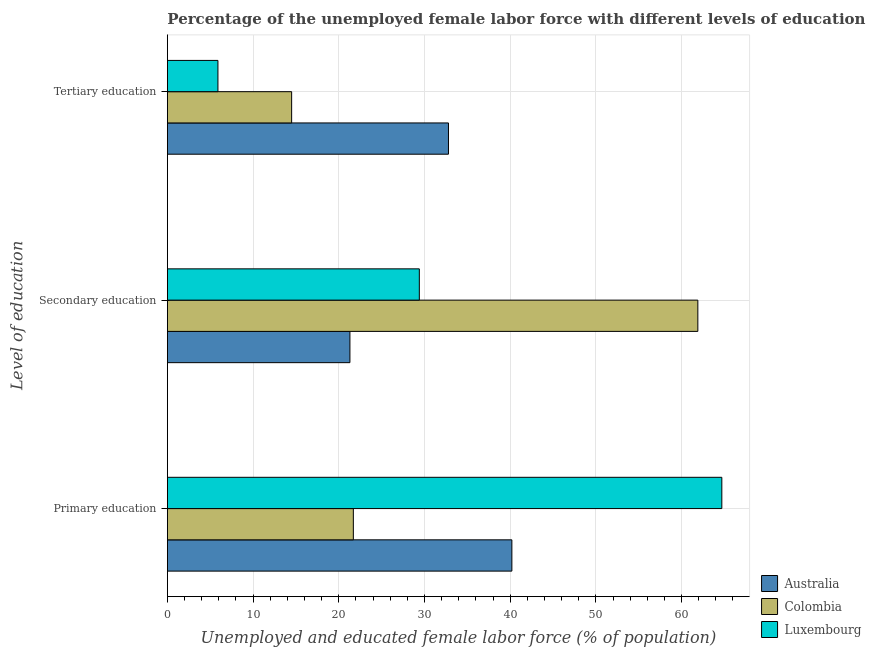How many different coloured bars are there?
Give a very brief answer. 3. How many groups of bars are there?
Give a very brief answer. 3. Are the number of bars per tick equal to the number of legend labels?
Give a very brief answer. Yes. How many bars are there on the 1st tick from the top?
Provide a succinct answer. 3. What is the label of the 2nd group of bars from the top?
Your answer should be very brief. Secondary education. What is the percentage of female labor force who received primary education in Colombia?
Offer a terse response. 21.7. Across all countries, what is the maximum percentage of female labor force who received primary education?
Ensure brevity in your answer.  64.7. Across all countries, what is the minimum percentage of female labor force who received secondary education?
Keep it short and to the point. 21.3. In which country was the percentage of female labor force who received tertiary education maximum?
Offer a terse response. Australia. In which country was the percentage of female labor force who received primary education minimum?
Offer a terse response. Colombia. What is the total percentage of female labor force who received tertiary education in the graph?
Provide a short and direct response. 53.2. What is the difference between the percentage of female labor force who received primary education in Colombia and that in Luxembourg?
Your answer should be compact. -43. What is the difference between the percentage of female labor force who received secondary education in Luxembourg and the percentage of female labor force who received primary education in Australia?
Make the answer very short. -10.8. What is the average percentage of female labor force who received tertiary education per country?
Give a very brief answer. 17.73. What is the difference between the percentage of female labor force who received tertiary education and percentage of female labor force who received secondary education in Australia?
Offer a very short reply. 11.5. In how many countries, is the percentage of female labor force who received primary education greater than 4 %?
Your answer should be very brief. 3. What is the ratio of the percentage of female labor force who received tertiary education in Luxembourg to that in Australia?
Your answer should be very brief. 0.18. Is the percentage of female labor force who received primary education in Australia less than that in Luxembourg?
Make the answer very short. Yes. Is the difference between the percentage of female labor force who received primary education in Luxembourg and Australia greater than the difference between the percentage of female labor force who received secondary education in Luxembourg and Australia?
Offer a very short reply. Yes. What is the difference between the highest and the second highest percentage of female labor force who received tertiary education?
Provide a succinct answer. 18.3. What is the difference between the highest and the lowest percentage of female labor force who received primary education?
Provide a short and direct response. 43. What does the 3rd bar from the top in Primary education represents?
Give a very brief answer. Australia. What does the 1st bar from the bottom in Primary education represents?
Provide a short and direct response. Australia. Is it the case that in every country, the sum of the percentage of female labor force who received primary education and percentage of female labor force who received secondary education is greater than the percentage of female labor force who received tertiary education?
Provide a short and direct response. Yes. Are all the bars in the graph horizontal?
Offer a terse response. Yes. How many countries are there in the graph?
Ensure brevity in your answer.  3. What is the difference between two consecutive major ticks on the X-axis?
Your answer should be very brief. 10. Does the graph contain any zero values?
Give a very brief answer. No. Does the graph contain grids?
Ensure brevity in your answer.  Yes. Where does the legend appear in the graph?
Your answer should be compact. Bottom right. How are the legend labels stacked?
Your response must be concise. Vertical. What is the title of the graph?
Provide a succinct answer. Percentage of the unemployed female labor force with different levels of education in countries. Does "Sao Tome and Principe" appear as one of the legend labels in the graph?
Give a very brief answer. No. What is the label or title of the X-axis?
Make the answer very short. Unemployed and educated female labor force (% of population). What is the label or title of the Y-axis?
Offer a very short reply. Level of education. What is the Unemployed and educated female labor force (% of population) of Australia in Primary education?
Your response must be concise. 40.2. What is the Unemployed and educated female labor force (% of population) of Colombia in Primary education?
Your answer should be very brief. 21.7. What is the Unemployed and educated female labor force (% of population) in Luxembourg in Primary education?
Give a very brief answer. 64.7. What is the Unemployed and educated female labor force (% of population) of Australia in Secondary education?
Your response must be concise. 21.3. What is the Unemployed and educated female labor force (% of population) in Colombia in Secondary education?
Your response must be concise. 61.9. What is the Unemployed and educated female labor force (% of population) in Luxembourg in Secondary education?
Offer a terse response. 29.4. What is the Unemployed and educated female labor force (% of population) of Australia in Tertiary education?
Make the answer very short. 32.8. What is the Unemployed and educated female labor force (% of population) of Luxembourg in Tertiary education?
Keep it short and to the point. 5.9. Across all Level of education, what is the maximum Unemployed and educated female labor force (% of population) of Australia?
Provide a short and direct response. 40.2. Across all Level of education, what is the maximum Unemployed and educated female labor force (% of population) of Colombia?
Keep it short and to the point. 61.9. Across all Level of education, what is the maximum Unemployed and educated female labor force (% of population) of Luxembourg?
Your answer should be compact. 64.7. Across all Level of education, what is the minimum Unemployed and educated female labor force (% of population) in Australia?
Make the answer very short. 21.3. Across all Level of education, what is the minimum Unemployed and educated female labor force (% of population) in Luxembourg?
Offer a very short reply. 5.9. What is the total Unemployed and educated female labor force (% of population) in Australia in the graph?
Give a very brief answer. 94.3. What is the total Unemployed and educated female labor force (% of population) in Colombia in the graph?
Your answer should be compact. 98.1. What is the total Unemployed and educated female labor force (% of population) in Luxembourg in the graph?
Your answer should be compact. 100. What is the difference between the Unemployed and educated female labor force (% of population) in Australia in Primary education and that in Secondary education?
Your answer should be compact. 18.9. What is the difference between the Unemployed and educated female labor force (% of population) of Colombia in Primary education and that in Secondary education?
Offer a terse response. -40.2. What is the difference between the Unemployed and educated female labor force (% of population) of Luxembourg in Primary education and that in Secondary education?
Offer a very short reply. 35.3. What is the difference between the Unemployed and educated female labor force (% of population) in Australia in Primary education and that in Tertiary education?
Give a very brief answer. 7.4. What is the difference between the Unemployed and educated female labor force (% of population) in Luxembourg in Primary education and that in Tertiary education?
Provide a short and direct response. 58.8. What is the difference between the Unemployed and educated female labor force (% of population) in Australia in Secondary education and that in Tertiary education?
Offer a very short reply. -11.5. What is the difference between the Unemployed and educated female labor force (% of population) in Colombia in Secondary education and that in Tertiary education?
Provide a succinct answer. 47.4. What is the difference between the Unemployed and educated female labor force (% of population) of Australia in Primary education and the Unemployed and educated female labor force (% of population) of Colombia in Secondary education?
Your answer should be very brief. -21.7. What is the difference between the Unemployed and educated female labor force (% of population) in Australia in Primary education and the Unemployed and educated female labor force (% of population) in Luxembourg in Secondary education?
Provide a short and direct response. 10.8. What is the difference between the Unemployed and educated female labor force (% of population) of Colombia in Primary education and the Unemployed and educated female labor force (% of population) of Luxembourg in Secondary education?
Offer a terse response. -7.7. What is the difference between the Unemployed and educated female labor force (% of population) of Australia in Primary education and the Unemployed and educated female labor force (% of population) of Colombia in Tertiary education?
Offer a very short reply. 25.7. What is the difference between the Unemployed and educated female labor force (% of population) of Australia in Primary education and the Unemployed and educated female labor force (% of population) of Luxembourg in Tertiary education?
Provide a short and direct response. 34.3. What is the difference between the Unemployed and educated female labor force (% of population) of Colombia in Primary education and the Unemployed and educated female labor force (% of population) of Luxembourg in Tertiary education?
Offer a terse response. 15.8. What is the average Unemployed and educated female labor force (% of population) in Australia per Level of education?
Provide a succinct answer. 31.43. What is the average Unemployed and educated female labor force (% of population) in Colombia per Level of education?
Ensure brevity in your answer.  32.7. What is the average Unemployed and educated female labor force (% of population) of Luxembourg per Level of education?
Your response must be concise. 33.33. What is the difference between the Unemployed and educated female labor force (% of population) of Australia and Unemployed and educated female labor force (% of population) of Colombia in Primary education?
Keep it short and to the point. 18.5. What is the difference between the Unemployed and educated female labor force (% of population) of Australia and Unemployed and educated female labor force (% of population) of Luxembourg in Primary education?
Offer a terse response. -24.5. What is the difference between the Unemployed and educated female labor force (% of population) of Colombia and Unemployed and educated female labor force (% of population) of Luxembourg in Primary education?
Provide a succinct answer. -43. What is the difference between the Unemployed and educated female labor force (% of population) of Australia and Unemployed and educated female labor force (% of population) of Colombia in Secondary education?
Your answer should be compact. -40.6. What is the difference between the Unemployed and educated female labor force (% of population) in Colombia and Unemployed and educated female labor force (% of population) in Luxembourg in Secondary education?
Provide a short and direct response. 32.5. What is the difference between the Unemployed and educated female labor force (% of population) of Australia and Unemployed and educated female labor force (% of population) of Luxembourg in Tertiary education?
Your answer should be very brief. 26.9. What is the difference between the Unemployed and educated female labor force (% of population) in Colombia and Unemployed and educated female labor force (% of population) in Luxembourg in Tertiary education?
Your response must be concise. 8.6. What is the ratio of the Unemployed and educated female labor force (% of population) of Australia in Primary education to that in Secondary education?
Offer a very short reply. 1.89. What is the ratio of the Unemployed and educated female labor force (% of population) in Colombia in Primary education to that in Secondary education?
Keep it short and to the point. 0.35. What is the ratio of the Unemployed and educated female labor force (% of population) in Luxembourg in Primary education to that in Secondary education?
Your answer should be compact. 2.2. What is the ratio of the Unemployed and educated female labor force (% of population) in Australia in Primary education to that in Tertiary education?
Provide a short and direct response. 1.23. What is the ratio of the Unemployed and educated female labor force (% of population) of Colombia in Primary education to that in Tertiary education?
Offer a very short reply. 1.5. What is the ratio of the Unemployed and educated female labor force (% of population) in Luxembourg in Primary education to that in Tertiary education?
Provide a short and direct response. 10.97. What is the ratio of the Unemployed and educated female labor force (% of population) in Australia in Secondary education to that in Tertiary education?
Your answer should be very brief. 0.65. What is the ratio of the Unemployed and educated female labor force (% of population) of Colombia in Secondary education to that in Tertiary education?
Provide a short and direct response. 4.27. What is the ratio of the Unemployed and educated female labor force (% of population) of Luxembourg in Secondary education to that in Tertiary education?
Provide a short and direct response. 4.98. What is the difference between the highest and the second highest Unemployed and educated female labor force (% of population) of Australia?
Keep it short and to the point. 7.4. What is the difference between the highest and the second highest Unemployed and educated female labor force (% of population) in Colombia?
Ensure brevity in your answer.  40.2. What is the difference between the highest and the second highest Unemployed and educated female labor force (% of population) in Luxembourg?
Ensure brevity in your answer.  35.3. What is the difference between the highest and the lowest Unemployed and educated female labor force (% of population) in Colombia?
Offer a terse response. 47.4. What is the difference between the highest and the lowest Unemployed and educated female labor force (% of population) of Luxembourg?
Your response must be concise. 58.8. 